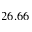<formula> <loc_0><loc_0><loc_500><loc_500>2 6 . 6 6</formula> 